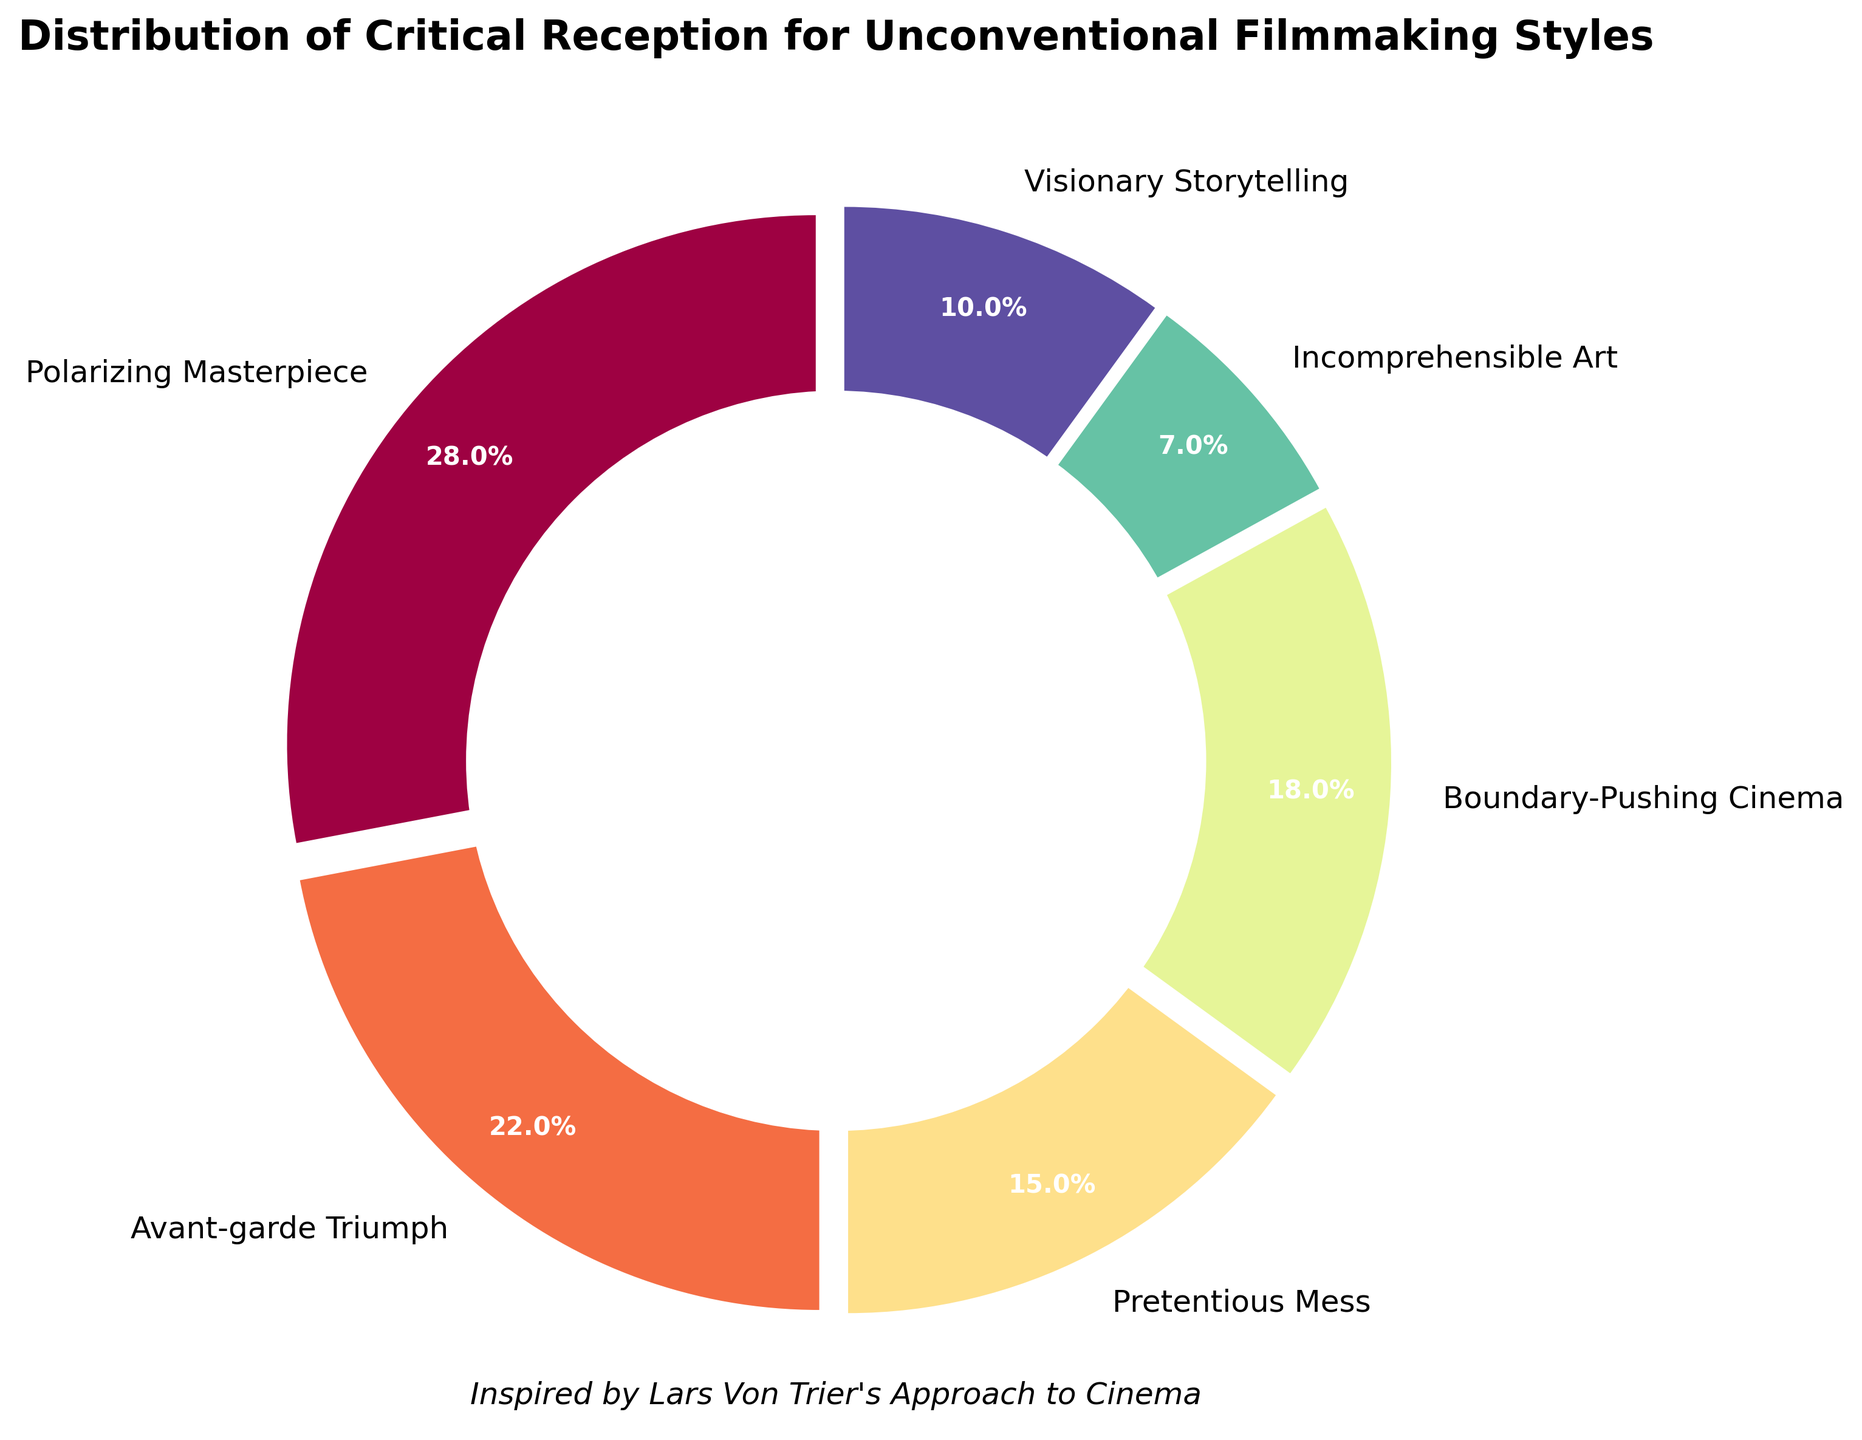What is the most frequent critical reception for unconventional filmmaking styles? The segment with the largest percentage is the most frequent. "Polarizing Masterpiece" has the highest percentage at 28%.
Answer: Polarizing Masterpiece Which two categories combined make up more than 50% of the critical reception? "Polarizing Masterpiece" (28%) and "Avant-garde Triumph" (22%) together total 50% exactly. Since both categories combined reach the threshold, they account for more than 50% of the critical reception.
Answer: Polarizing Masterpiece and Avant-garde Triumph How does the percentage of "Visionary Storytelling" compare to "Pretentious Mess"? "Visionary Storytelling" has a percentage of 10%, while "Pretentious Mess" has a percentage of 15%.
Answer: Visionary Storytelling is 5% less than Pretentious Mess What is the percentage difference between the highest and lowest critical reception categories? The highest percentage is "Polarizing Masterpiece" at 28%, and the lowest is "Incomprehensible Art" at 7%. The difference is calculated as 28% - 7% = 21%.
Answer: 21% Which segments have a combined total under 25%? "Pretentious Mess" (15%), "Incomprehensible Art" (7%), and "Visionary Storytelling" (10%) each are less than 25%. Check the combinations: 15% + 7% = 22%, 15% + 10% = 25%, and 7% + 10% = 17%. Thus, the combinations that fulfill the requirement are "Pretentious Mess" and "Incomprehensible Art"; "Incomprehensible Art" and "Visionary Storytelling".
Answer: Pretentious Mess and Incomprehensible Art; Incomprehensible Art and Visionary Storytelling What is the visual difference between "Avant-garde Triumph" and "Boundary-Pushing Cinema"? "Avant-garde Triumph" is labeled at 22% and has a slightly larger segment than "Boundary-Pushing Cinema" which is labeled at 18%. Visually, "Avant-garde Triumph" appears more substantial due to its greater percentage.
Answer: Avant-garde Triumph is 4% more Can you find the segment that accounts for more than "Visionary Storytelling" but less than "Boundary-Pushing Cinema"? "Visionary Storytelling" has a percentage of 10%, and "Boundary-Pushing Cinema" is at 18%. The segment "Avant-garde Triumph" at 22% is too high and "Pretentious Mess" at 15% fits in this range.
Answer: Pretentious Mess Which section occupies the smallest portion of the pie chart? The segment with the lowest percentage is the smallest visually. "Incomprehensible Art" has the lowest percentage at 7%.
Answer: Incomprehensible Art What percentage of the total critical reception do the segments "Incomprehensible Art" and "Visionary Storytelling" account for together? Adding the percentages of "Incomprehensible Art" (7%) and "Visionary Storytelling" (10%) gives 7% + 10% = 17%.
Answer: 17% 